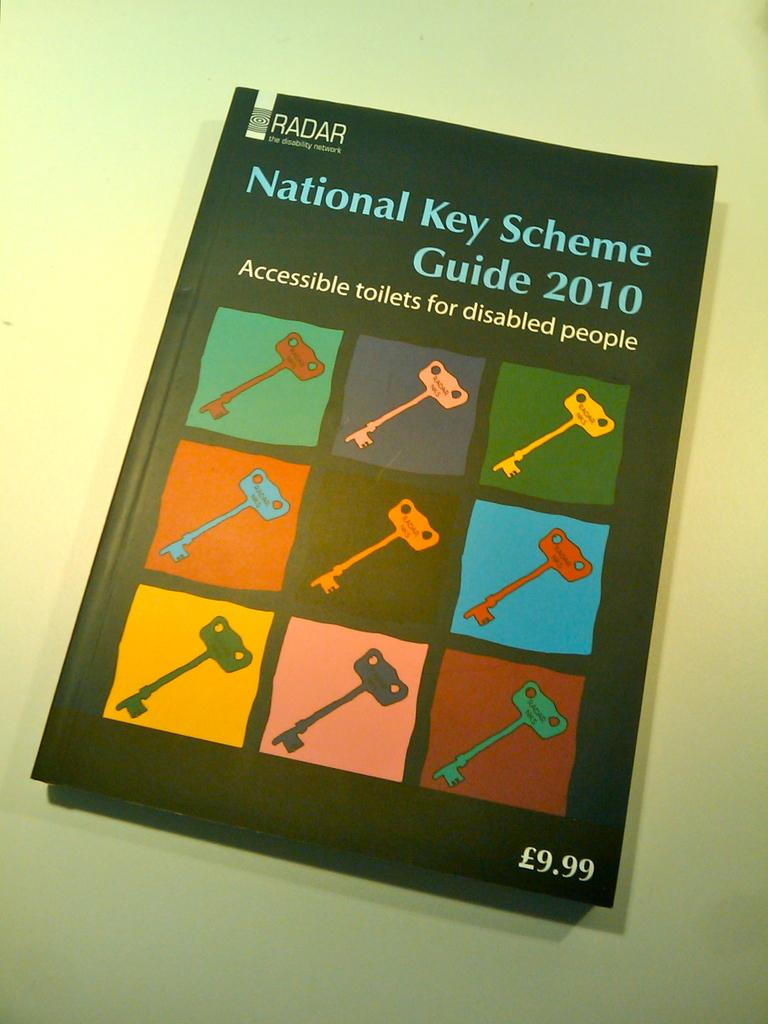<image>
Describe the image concisely. Book that shows different colored keys and is titled "National Key Scheme". 